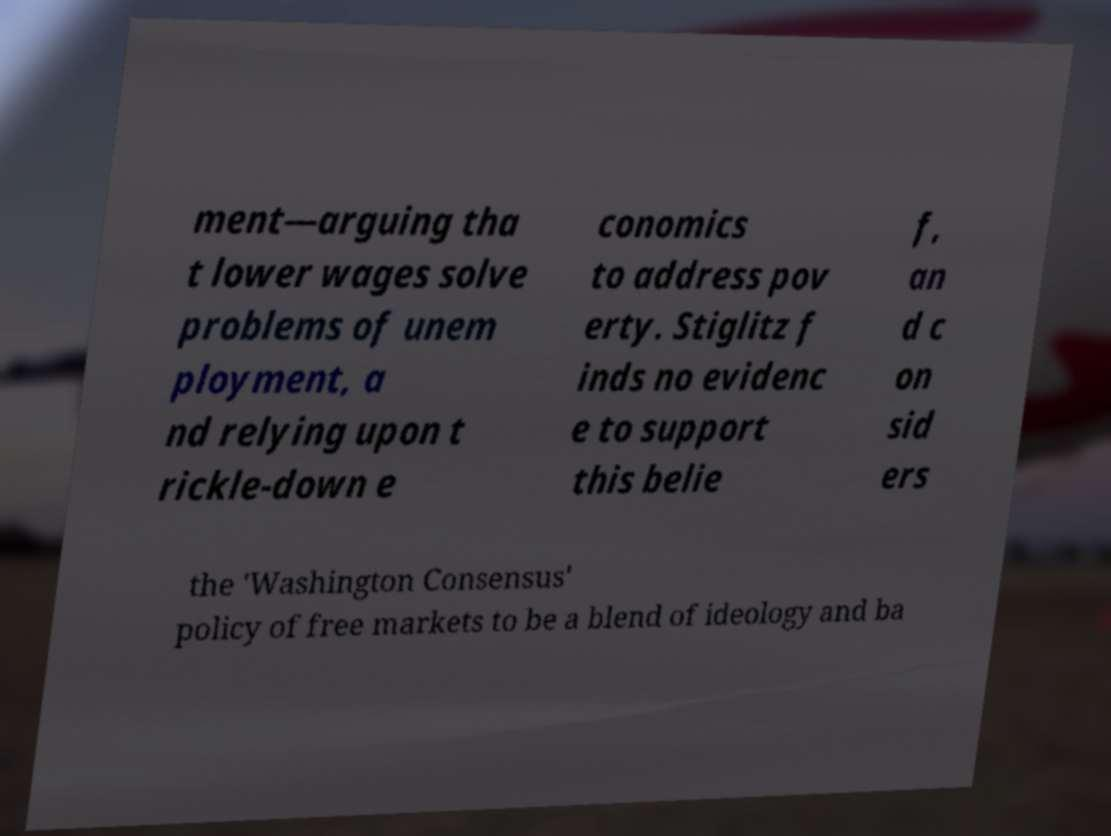I need the written content from this picture converted into text. Can you do that? ment—arguing tha t lower wages solve problems of unem ployment, a nd relying upon t rickle-down e conomics to address pov erty. Stiglitz f inds no evidenc e to support this belie f, an d c on sid ers the 'Washington Consensus' policy of free markets to be a blend of ideology and ba 